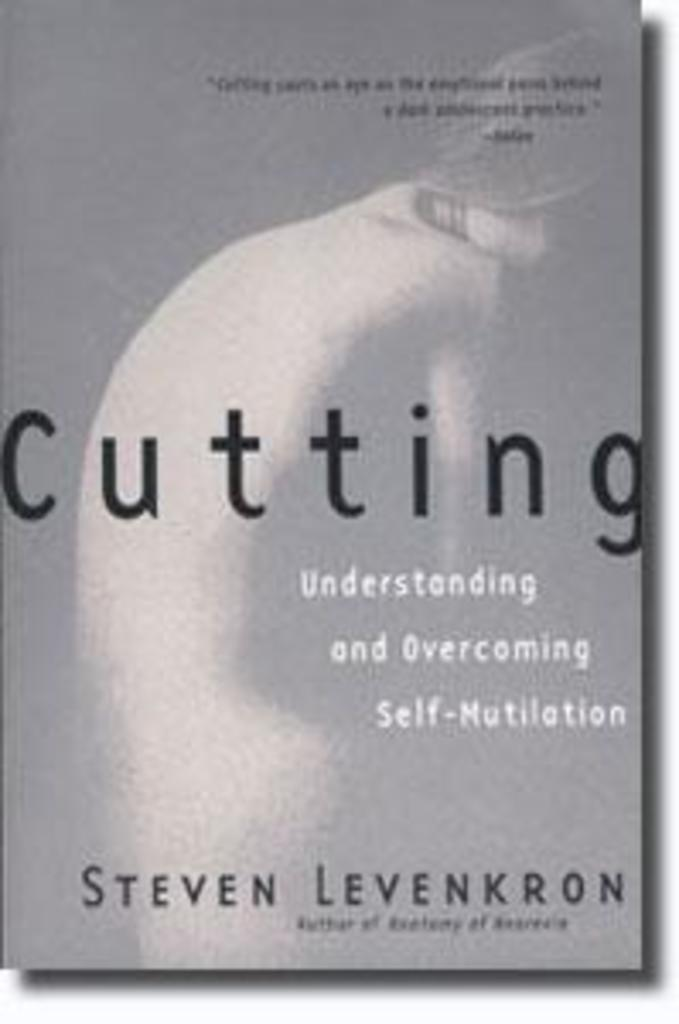<image>
Relay a brief, clear account of the picture shown. A self help book by Steven Levenkron has the image of a woman on the cover. 